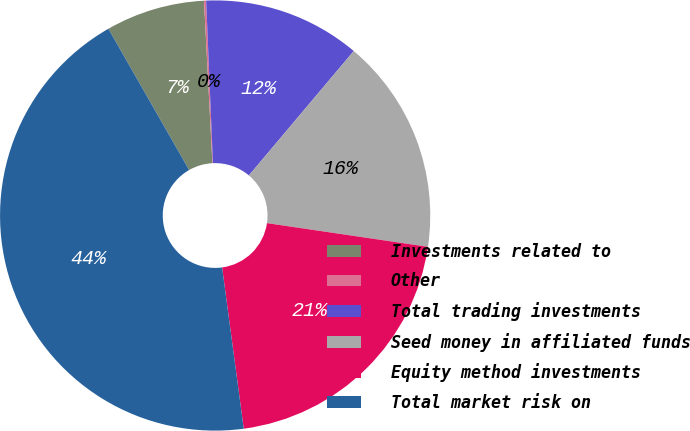Convert chart to OTSL. <chart><loc_0><loc_0><loc_500><loc_500><pie_chart><fcel>Investments related to<fcel>Other<fcel>Total trading investments<fcel>Seed money in affiliated funds<fcel>Equity method investments<fcel>Total market risk on<nl><fcel>7.44%<fcel>0.16%<fcel>11.81%<fcel>16.18%<fcel>20.55%<fcel>43.85%<nl></chart> 